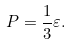Convert formula to latex. <formula><loc_0><loc_0><loc_500><loc_500>P = \frac { 1 } { 3 } \varepsilon .</formula> 